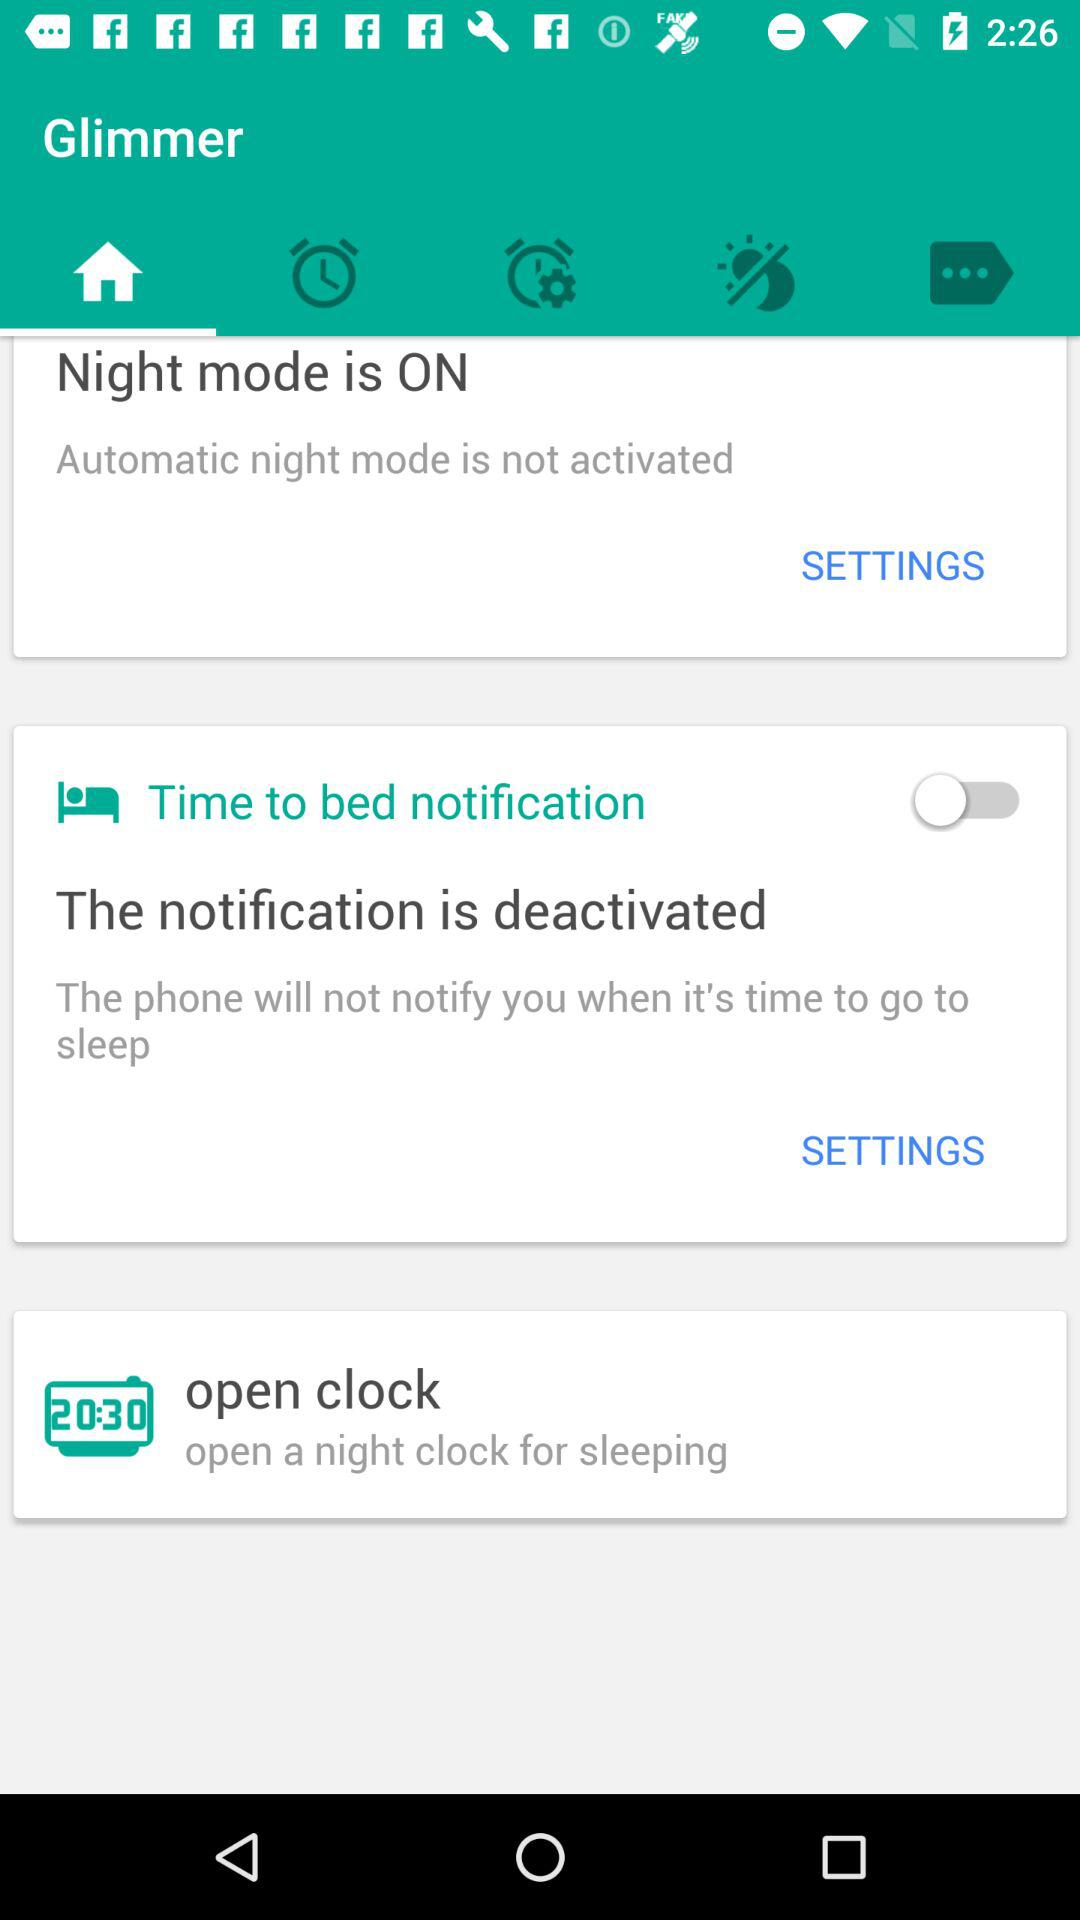What is the status of "Night mode"? The status is "on". 